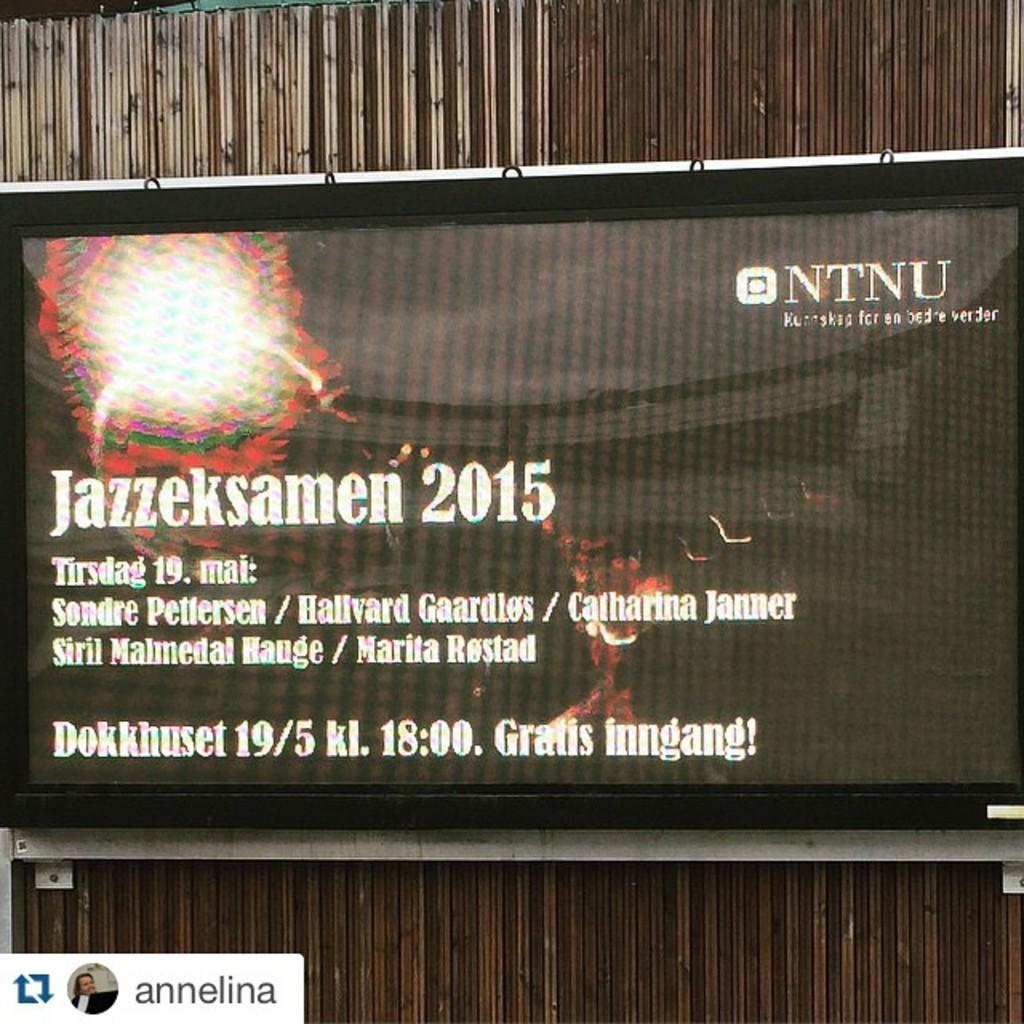<image>
Give a short and clear explanation of the subsequent image. A TV mounted on a wall with an advertisement that says Jazzeksamen 2015. 